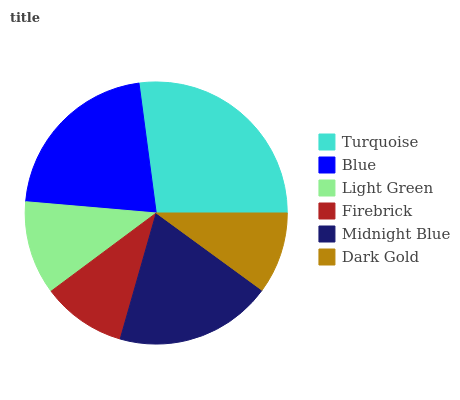Is Dark Gold the minimum?
Answer yes or no. Yes. Is Turquoise the maximum?
Answer yes or no. Yes. Is Blue the minimum?
Answer yes or no. No. Is Blue the maximum?
Answer yes or no. No. Is Turquoise greater than Blue?
Answer yes or no. Yes. Is Blue less than Turquoise?
Answer yes or no. Yes. Is Blue greater than Turquoise?
Answer yes or no. No. Is Turquoise less than Blue?
Answer yes or no. No. Is Midnight Blue the high median?
Answer yes or no. Yes. Is Light Green the low median?
Answer yes or no. Yes. Is Blue the high median?
Answer yes or no. No. Is Turquoise the low median?
Answer yes or no. No. 